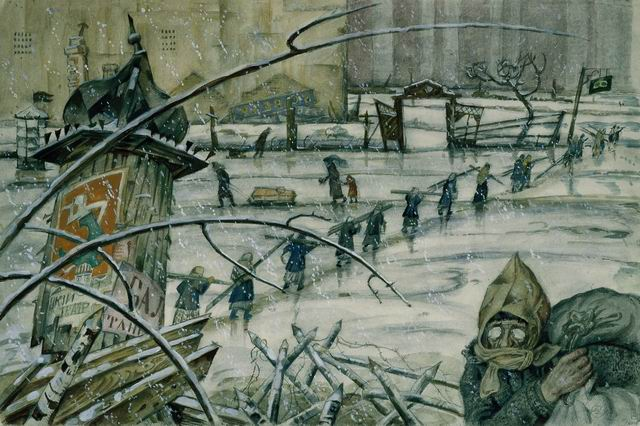What does this image tell you about the period it depicts? The image seems to depict a scene from a wartime period, characterized by the harsh winter and the overall sense of desolation. The presence of people in heavy winter clothing, some wearing gas masks, suggests a time of great hardship. The dilapidated state of the cityscape, coupled with the dreary weather conditions, likely indicates a setting during or after a major conflict, possibly World War II or a similar historical event involving widespread urban destruction and civilian suffering. 